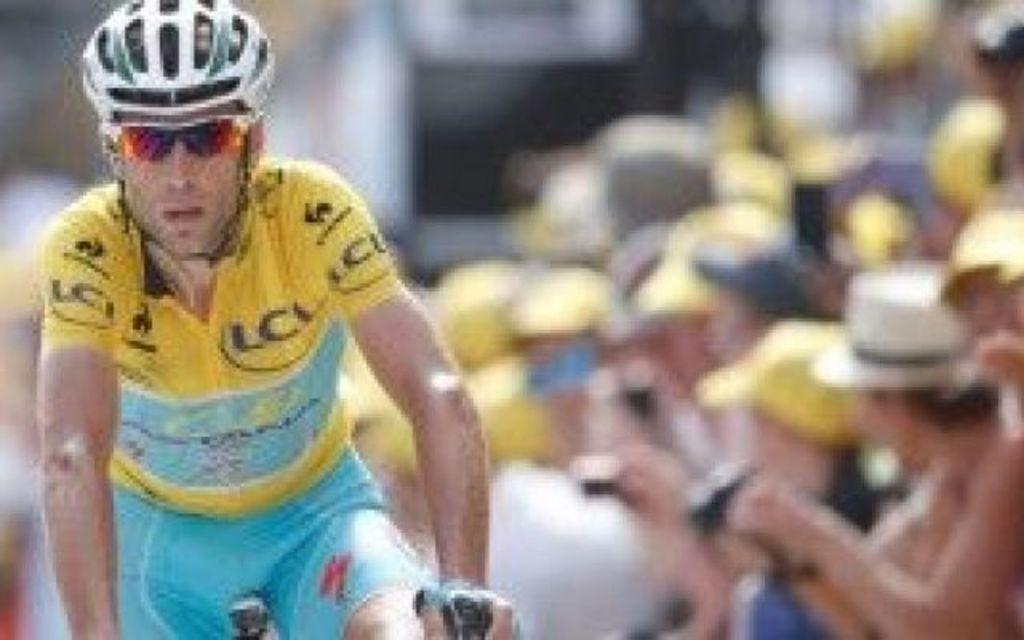Who is the person in the image? There is a man in the image. What is the man wearing? The man is wearing clothes, goggles, and a helmet. What is the man doing in the image? The man is riding a bicycle. Can you describe the bicycle in the image? The bicycle is visible in the image. What is the condition of the background in the image? The background of the image is blurred. What is the angle of the man's hands on the handlebars in the image? There is no specific angle mentioned for the man's hands on the handlebars in the image. Can you tell me about the man's sister in the image? There is no mention of a sister in the image or in the provided facts. 